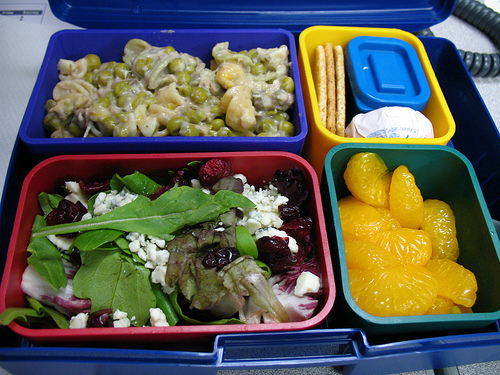<image>
Can you confirm if the orange is in the container? Yes. The orange is contained within or inside the container, showing a containment relationship. 